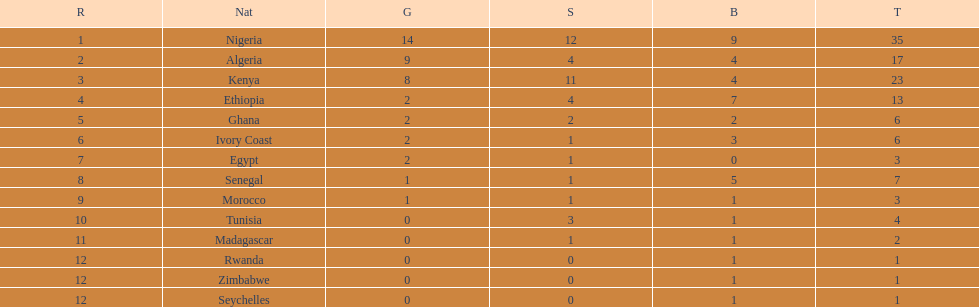The team with the most gold medals Nigeria. 